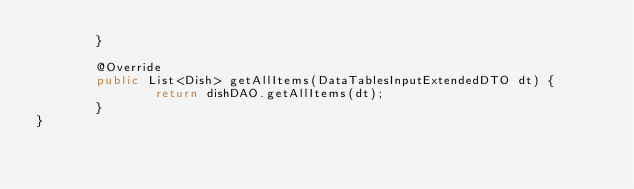Convert code to text. <code><loc_0><loc_0><loc_500><loc_500><_Java_>        }

        @Override
        public List<Dish> getAllItems(DataTablesInputExtendedDTO dt) {
                return dishDAO.getAllItems(dt);
        }
}
</code> 